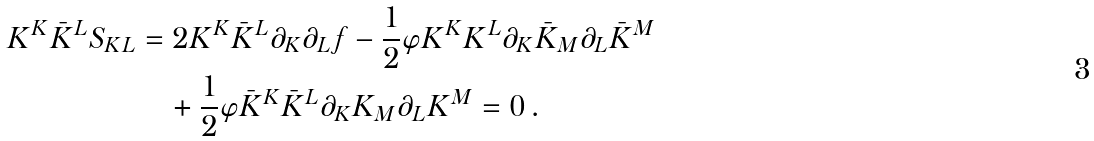<formula> <loc_0><loc_0><loc_500><loc_500>K ^ { K } \bar { K } ^ { L } S _ { K L } & = 2 K ^ { K } \bar { K } ^ { L } \partial _ { K } \partial _ { L } { f } - \frac { 1 } { 2 } \varphi K ^ { K } K ^ { L } \partial _ { K } { \bar { K } _ { M } } \partial _ { L } { \bar { K } ^ { M } } \\ & \quad + \frac { 1 } { 2 } \varphi \bar { K } ^ { K } \bar { K } ^ { L } \partial _ { K } { K _ { M } } \partial _ { L } { K ^ { M } } = 0 \, .</formula> 